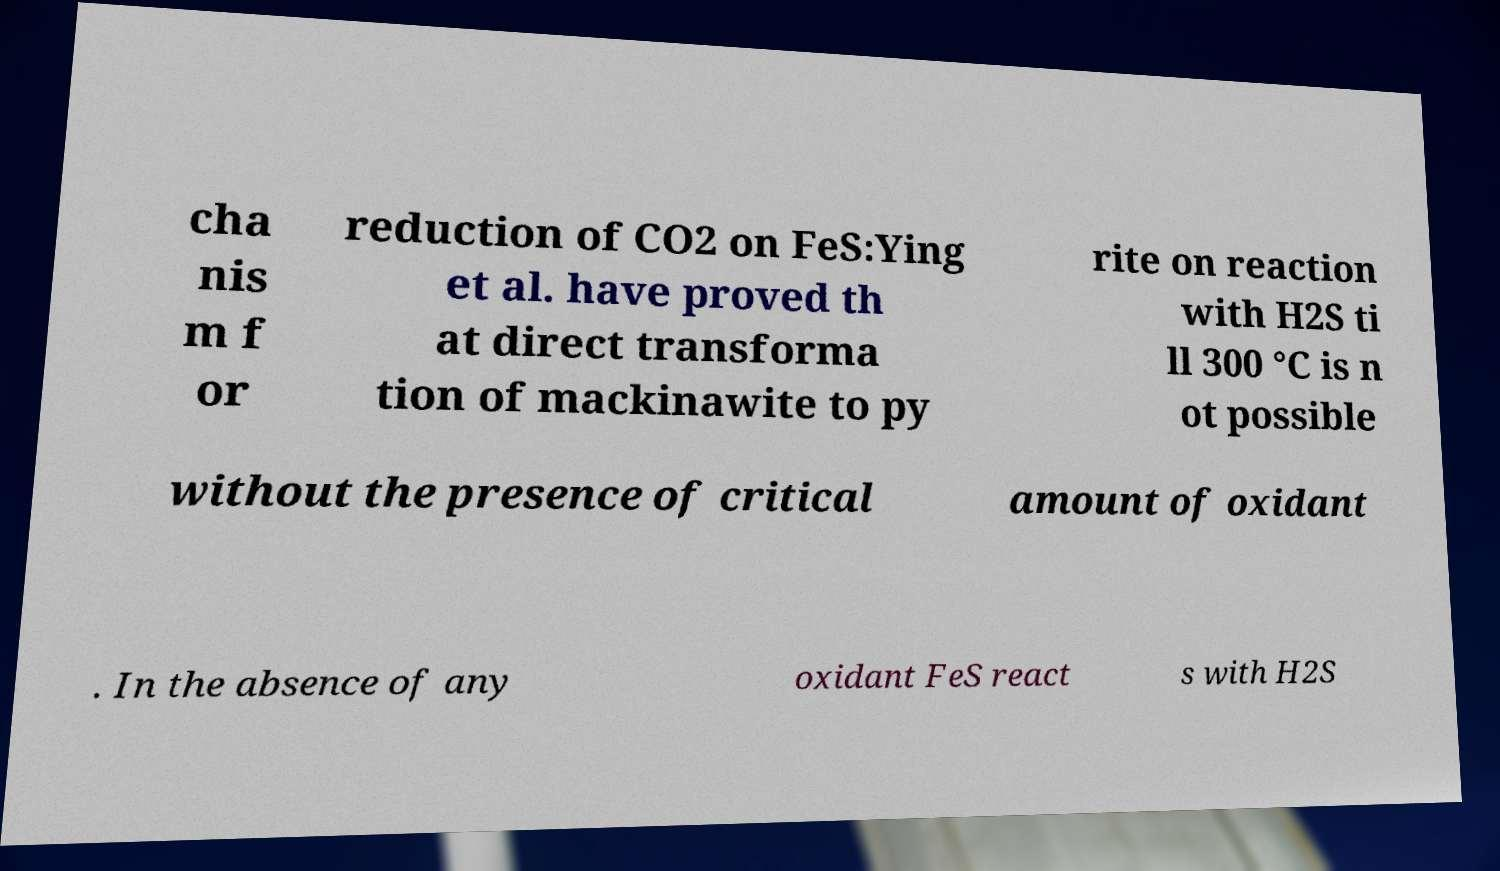Could you assist in decoding the text presented in this image and type it out clearly? cha nis m f or reduction of CO2 on FeS:Ying et al. have proved th at direct transforma tion of mackinawite to py rite on reaction with H2S ti ll 300 °C is n ot possible without the presence of critical amount of oxidant . In the absence of any oxidant FeS react s with H2S 